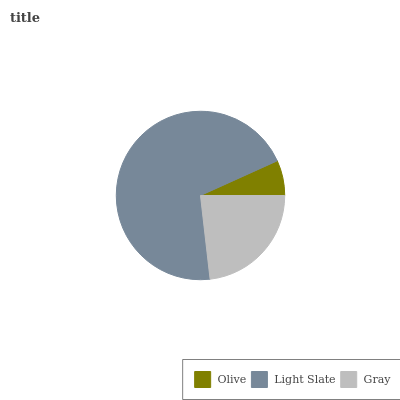Is Olive the minimum?
Answer yes or no. Yes. Is Light Slate the maximum?
Answer yes or no. Yes. Is Gray the minimum?
Answer yes or no. No. Is Gray the maximum?
Answer yes or no. No. Is Light Slate greater than Gray?
Answer yes or no. Yes. Is Gray less than Light Slate?
Answer yes or no. Yes. Is Gray greater than Light Slate?
Answer yes or no. No. Is Light Slate less than Gray?
Answer yes or no. No. Is Gray the high median?
Answer yes or no. Yes. Is Gray the low median?
Answer yes or no. Yes. Is Olive the high median?
Answer yes or no. No. Is Light Slate the low median?
Answer yes or no. No. 